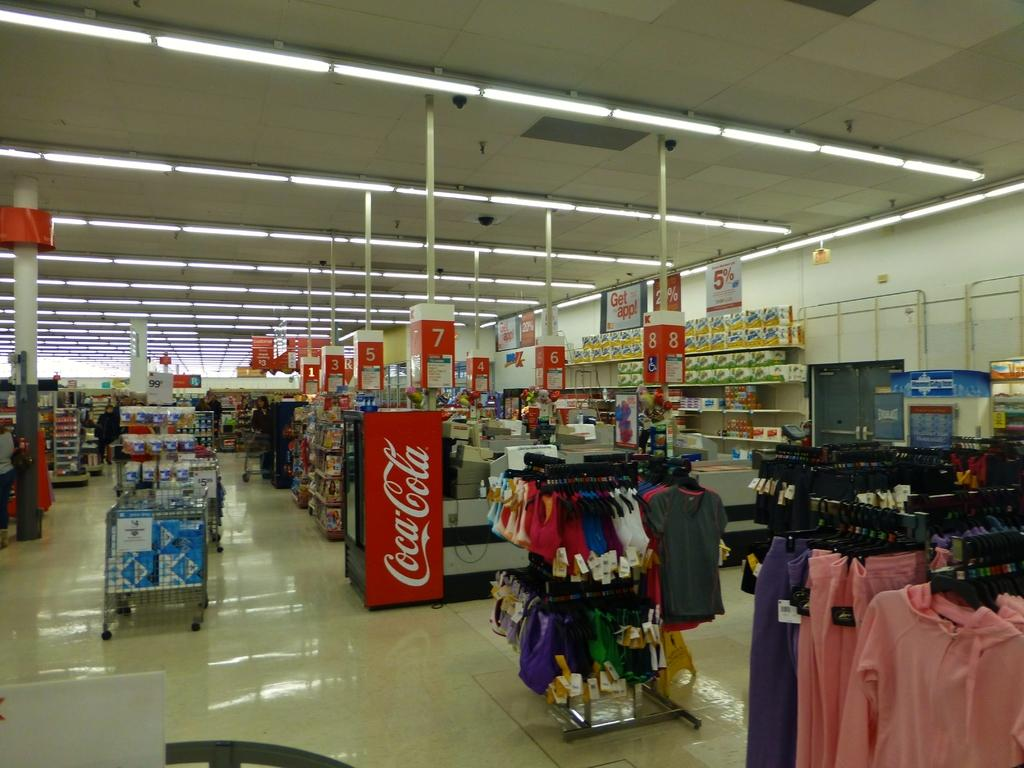<image>
Create a compact narrative representing the image presented. A big box store with clothing on display and a Coca-cola cooler 